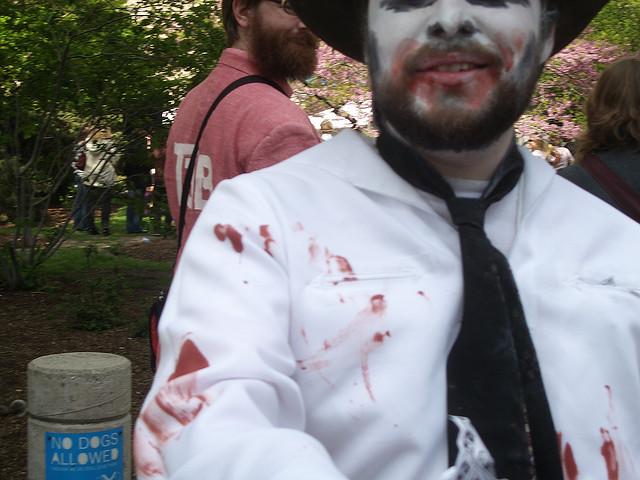Is the man wearing a tie?
Give a very brief answer. Yes. What color is the man's tie?
Quick response, please. Black. Does he have makeup on?
Write a very short answer. Yes. Is tooth hygiene important for overall good health?
Keep it brief. Yes. Does the man have a beard?
Concise answer only. Yes. What does this man have on his face?
Give a very brief answer. Paint. Are they drinking beer?
Give a very brief answer. No. What are the boys doing?
Concise answer only. Playing. Is a wheel visible?
Quick response, please. No. 